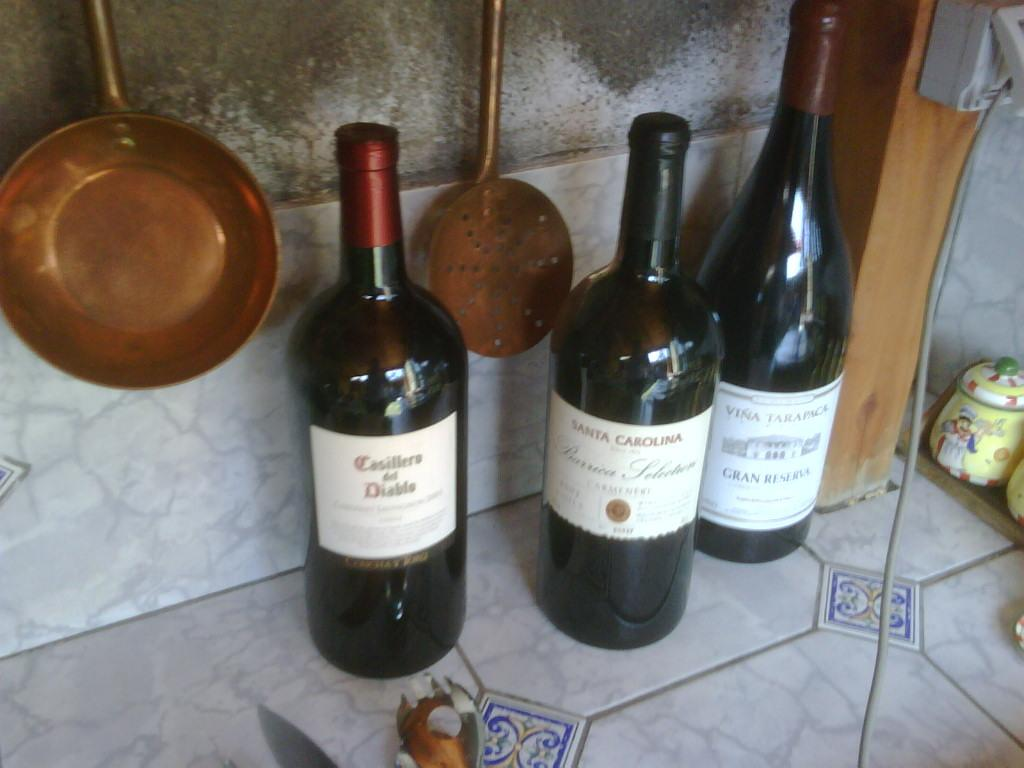<image>
Summarize the visual content of the image. Three different bottles of wine stand on a counter, the middle of which is from the Santa Carolina winery. 